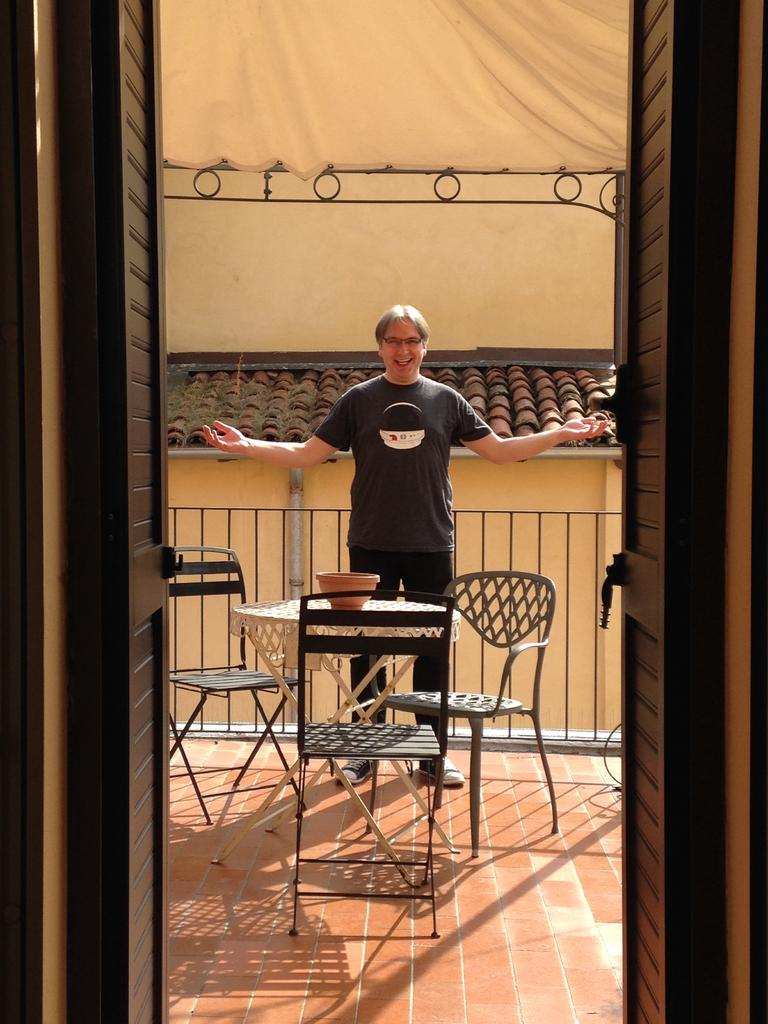What is the main subject in the image? There is a man standing in the image. What object is on the table in the image? There is a bowl on a table in the image. Are there any other furniture items visible in the image? Yes, there are chairs visible in the image. What type of trade is being conducted in the image? There is no indication of any trade being conducted in the image. What can be seen in the man's teeth in the image? There is no information about the man's teeth in the image. 